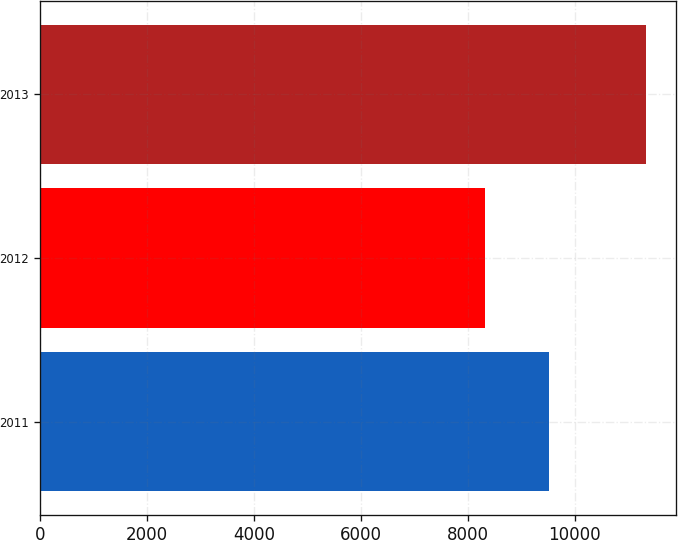Convert chart. <chart><loc_0><loc_0><loc_500><loc_500><bar_chart><fcel>2011<fcel>2012<fcel>2013<nl><fcel>9506<fcel>8323<fcel>11321<nl></chart> 